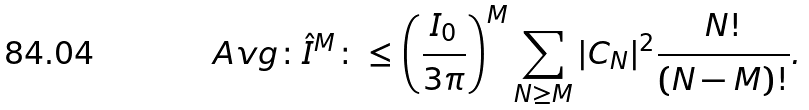Convert formula to latex. <formula><loc_0><loc_0><loc_500><loc_500>\ A v g { \colon \hat { I } ^ { M } \colon } \leq \left ( \frac { I _ { 0 } } { 3 \pi } \right ) ^ { M } \sum _ { N \geq M } | C _ { N } | ^ { 2 } \frac { N ! } { ( N - M ) ! } .</formula> 